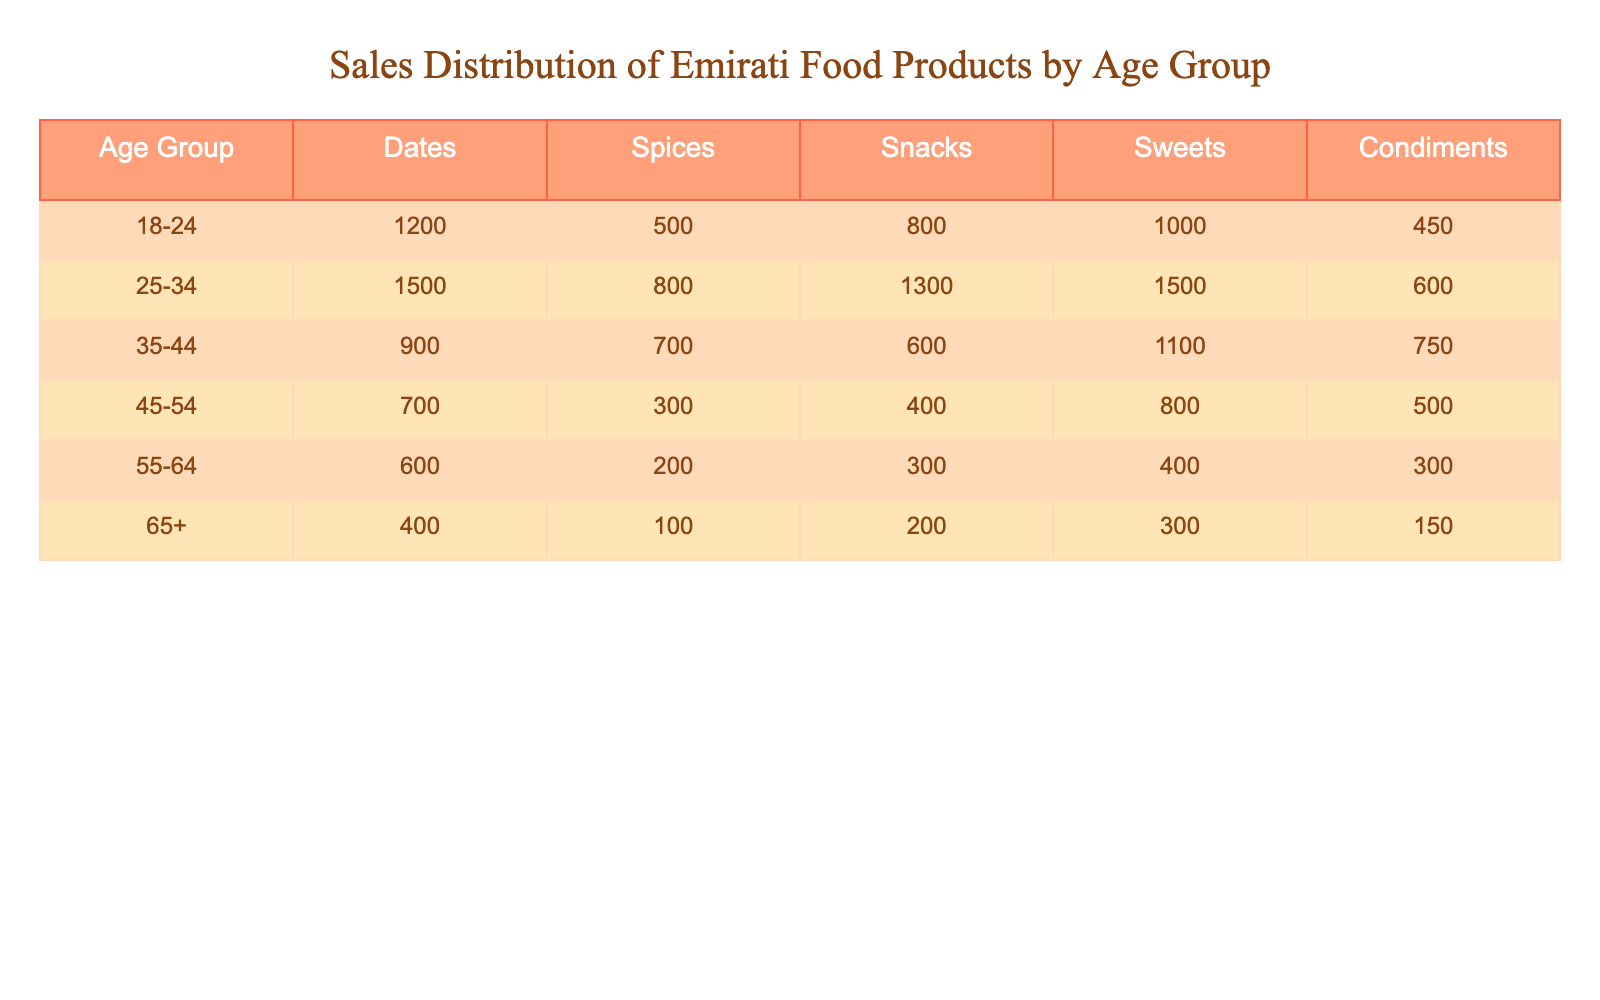What is the total sales of snacks for the age group 25-34? In the table, the sales of snacks for the age group 25-34 is directly indicated as 1300.
Answer: 1300 Which age group has the highest sales of spices? Looking through the spices column, the age group 25-34 has the highest sales at 800, compared to other age groups.
Answer: 25-34 What is the average sales of sweets across all age groups? To find the average, we first sum the sales of sweets: 1000 + 1500 + 600 + 400 + 300 + 200 = 4000. Then, we divide by the number of age groups, which is 6: 4000/6 = 666.67.
Answer: 666.67 Is there an age group that has more than 1000 sales in condiments? By examining the condiments column, the age groups 25-34 (600), 35-44 (750), and 45-54 (500) all have sales less than 1000. Therefore, there is no age group with more than 1000 sales in condiments.
Answer: No What is the difference in total sales between the 18-24 and 35-44 age groups for all products combined? For 18-24, total sales are 1200 + 500 + 800 + 1000 + 450 = 3950. For 35-44, total sales are 900 + 700 + 600 + 1100 + 750 = 4060. The difference is 4060 - 3950 = 110.
Answer: 110 Which food product has the lowest sales in the age group 55-64? In the age group 55-64, the sales for each product are 600 (Spices), 200 (Snacks), 300 (Sweets), 400 (Condiments). The lowest sales are for snacks at 200.
Answer: Snacks What is the total sales of all products for the age group 65+? For the age group 65+, the sales of all products are: 400 (Spices) + 100 (Snacks) + 200 (Sweets) + 300 (Condiments) = 1000.
Answer: 1000 Which age group is buying the highest amount of sweets, and how much are they buying? Reviewing the sweets column, the age group 25-34 has the highest sales of sweets at 1500, surpassing all other age groups.
Answer: 25-34, 1500 Is the total sales of snacks for ages 35-44 greater than the total sales of spices for ages 18-24? The sales for snacks in the age group 35-44 is 600, while for spices in age group 18-24, it is 500. Since 600 is greater than 500, the answer is yes.
Answer: Yes 